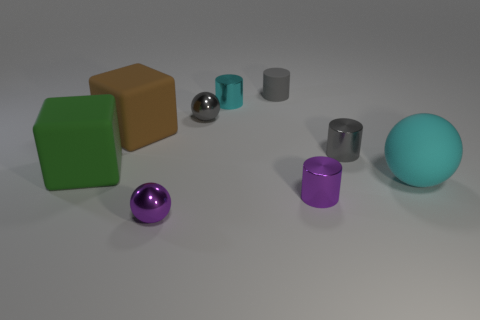There is a purple object left of the small cyan object that is to the right of the purple shiny sphere; what is its size?
Offer a terse response. Small. Are there any tiny shiny spheres of the same color as the small rubber cylinder?
Your response must be concise. Yes. Are there the same number of tiny metal cylinders that are behind the matte sphere and small green rubber cylinders?
Offer a very short reply. No. What number of small gray matte objects are there?
Your response must be concise. 1. There is a rubber thing that is in front of the big brown thing and on the right side of the purple shiny ball; what shape is it?
Provide a short and direct response. Sphere. There is a small cylinder to the left of the small gray matte object; is its color the same as the small sphere on the right side of the purple ball?
Provide a succinct answer. No. What is the size of the object that is the same color as the large rubber ball?
Offer a terse response. Small. Are there any gray cylinders made of the same material as the large green cube?
Provide a short and direct response. Yes. Are there an equal number of small rubber things right of the big cyan rubber object and small gray matte cylinders in front of the gray rubber cylinder?
Your answer should be very brief. Yes. There is a purple thing that is left of the tiny gray metallic sphere; how big is it?
Provide a short and direct response. Small. 